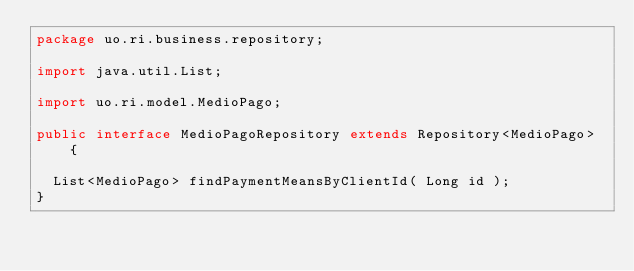Convert code to text. <code><loc_0><loc_0><loc_500><loc_500><_Java_>package uo.ri.business.repository;

import java.util.List;

import uo.ri.model.MedioPago;

public interface MedioPagoRepository extends Repository<MedioPago> {

	List<MedioPago> findPaymentMeansByClientId( Long id );
}
</code> 